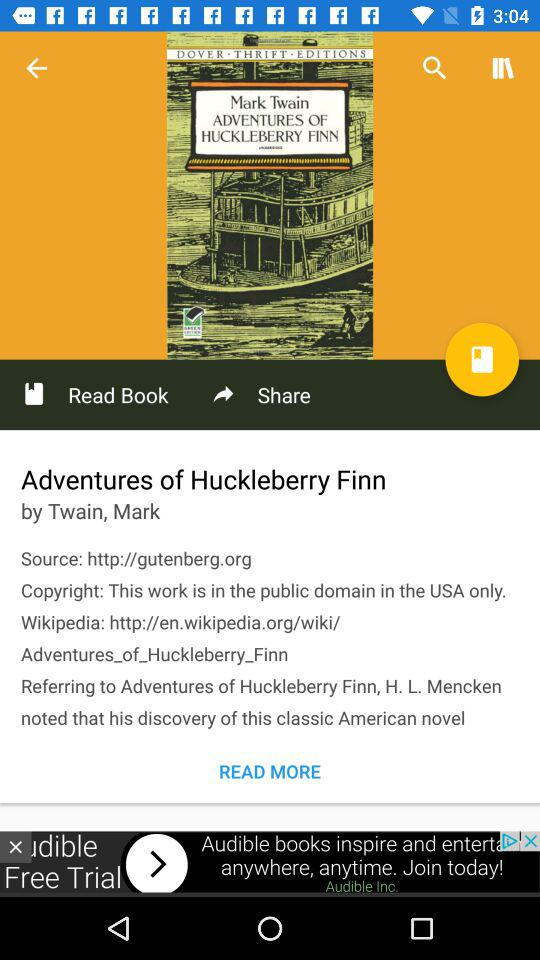What is the author's name? The author's name is Mark Twain. 